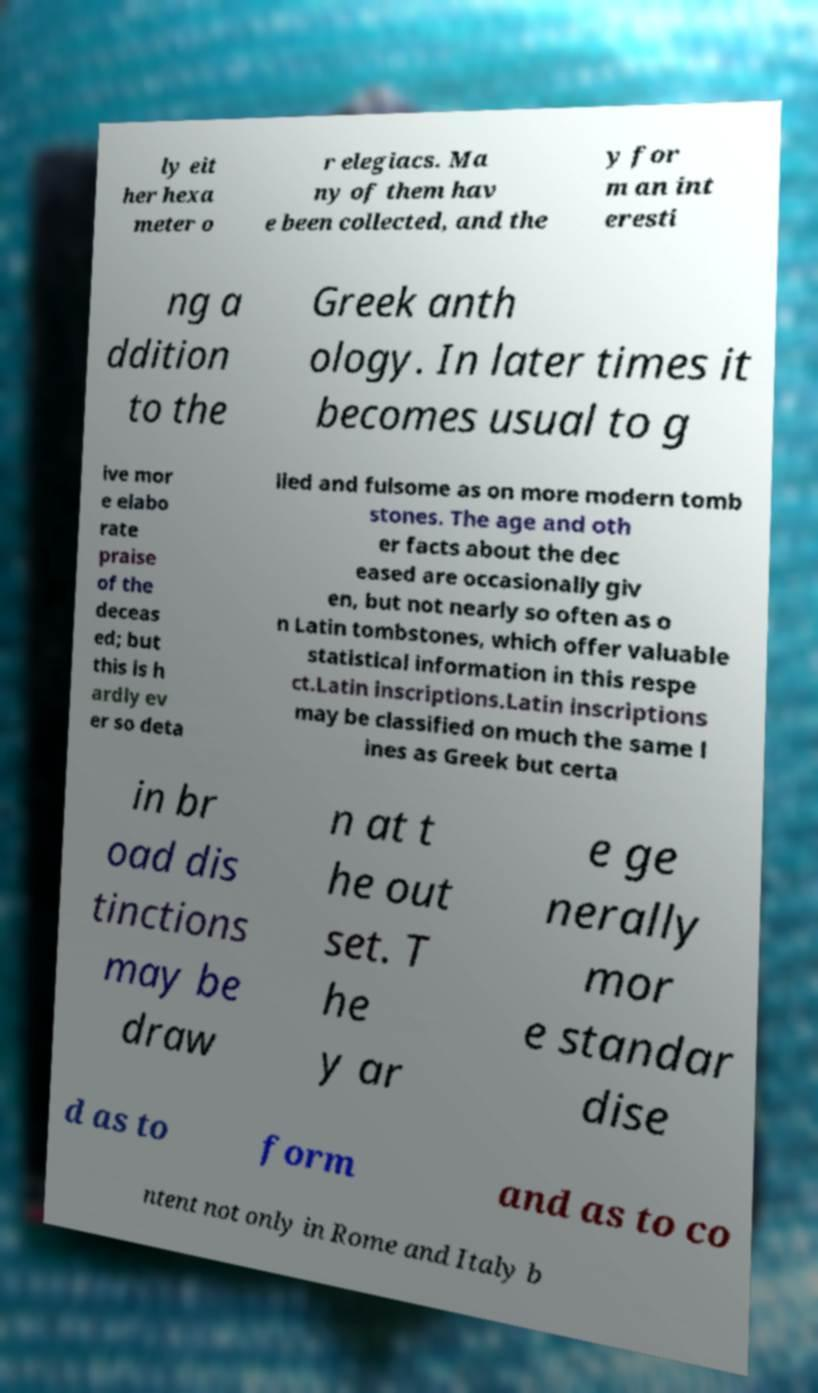I need the written content from this picture converted into text. Can you do that? ly eit her hexa meter o r elegiacs. Ma ny of them hav e been collected, and the y for m an int eresti ng a ddition to the Greek anth ology. In later times it becomes usual to g ive mor e elabo rate praise of the deceas ed; but this is h ardly ev er so deta iled and fulsome as on more modern tomb stones. The age and oth er facts about the dec eased are occasionally giv en, but not nearly so often as o n Latin tombstones, which offer valuable statistical information in this respe ct.Latin inscriptions.Latin inscriptions may be classified on much the same l ines as Greek but certa in br oad dis tinctions may be draw n at t he out set. T he y ar e ge nerally mor e standar dise d as to form and as to co ntent not only in Rome and Italy b 